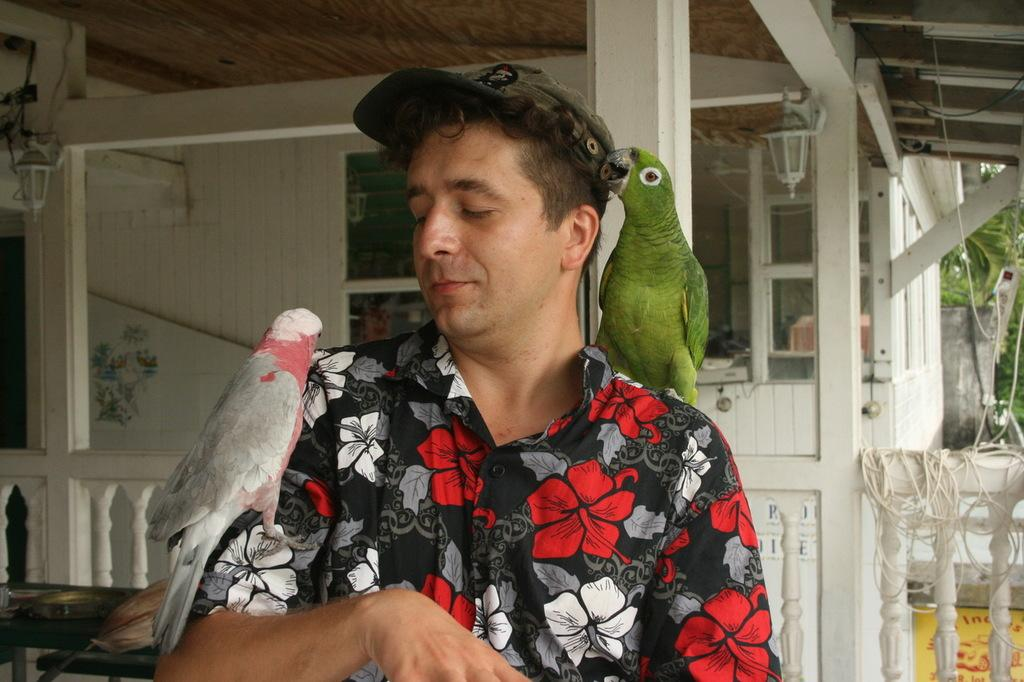Who is present in the image? There is a man in the image. What is on the man's right shoulder? There is a parrot on the man's right shoulder. What is on the man's left arm? There is a parrot on the man's left arm. What type of hen can be seen on the man's head in the image? There is no hen present in the image; only parrots are visible on the man's right shoulder and left arm. 